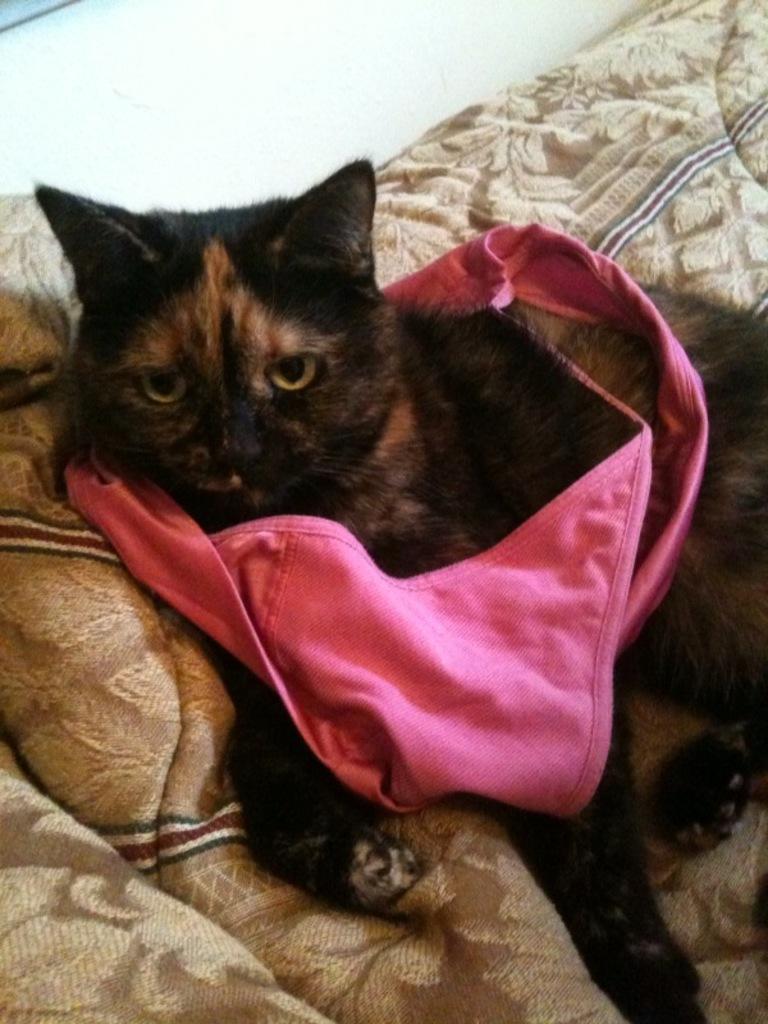Please provide a concise description of this image. In this image we can see a black color cat with a pink color cloth on it is lying on the couch. 